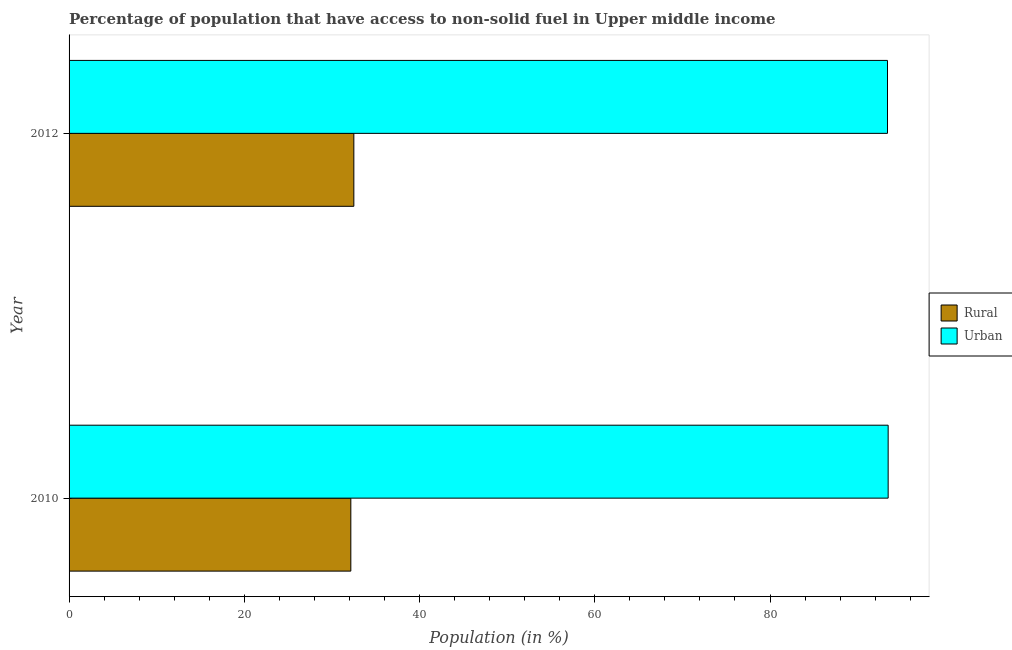Are the number of bars per tick equal to the number of legend labels?
Give a very brief answer. Yes. Are the number of bars on each tick of the Y-axis equal?
Offer a terse response. Yes. In how many cases, is the number of bars for a given year not equal to the number of legend labels?
Your response must be concise. 0. What is the rural population in 2012?
Your answer should be very brief. 32.5. Across all years, what is the maximum rural population?
Make the answer very short. 32.5. Across all years, what is the minimum urban population?
Your answer should be very brief. 93.41. In which year was the urban population maximum?
Give a very brief answer. 2010. What is the total rural population in the graph?
Provide a succinct answer. 64.66. What is the difference between the rural population in 2010 and that in 2012?
Offer a very short reply. -0.34. What is the difference between the urban population in 2010 and the rural population in 2012?
Give a very brief answer. 60.98. What is the average rural population per year?
Offer a very short reply. 32.33. In the year 2010, what is the difference between the urban population and rural population?
Keep it short and to the point. 61.33. In how many years, is the rural population greater than 32 %?
Keep it short and to the point. 2. What is the ratio of the rural population in 2010 to that in 2012?
Offer a terse response. 0.99. Is the urban population in 2010 less than that in 2012?
Ensure brevity in your answer.  No. What does the 1st bar from the top in 2010 represents?
Your answer should be very brief. Urban. What does the 2nd bar from the bottom in 2010 represents?
Give a very brief answer. Urban. How many bars are there?
Give a very brief answer. 4. Are the values on the major ticks of X-axis written in scientific E-notation?
Your answer should be very brief. No. Does the graph contain any zero values?
Offer a very short reply. No. Does the graph contain grids?
Provide a short and direct response. No. How many legend labels are there?
Offer a terse response. 2. What is the title of the graph?
Offer a very short reply. Percentage of population that have access to non-solid fuel in Upper middle income. Does "Travel Items" appear as one of the legend labels in the graph?
Make the answer very short. No. What is the Population (in %) of Rural in 2010?
Provide a succinct answer. 32.16. What is the Population (in %) of Urban in 2010?
Keep it short and to the point. 93.49. What is the Population (in %) in Rural in 2012?
Provide a succinct answer. 32.5. What is the Population (in %) of Urban in 2012?
Offer a very short reply. 93.41. Across all years, what is the maximum Population (in %) of Rural?
Your answer should be very brief. 32.5. Across all years, what is the maximum Population (in %) of Urban?
Give a very brief answer. 93.49. Across all years, what is the minimum Population (in %) in Rural?
Keep it short and to the point. 32.16. Across all years, what is the minimum Population (in %) in Urban?
Give a very brief answer. 93.41. What is the total Population (in %) of Rural in the graph?
Ensure brevity in your answer.  64.66. What is the total Population (in %) of Urban in the graph?
Give a very brief answer. 186.9. What is the difference between the Population (in %) of Rural in 2010 and that in 2012?
Provide a short and direct response. -0.34. What is the difference between the Population (in %) of Urban in 2010 and that in 2012?
Your response must be concise. 0.08. What is the difference between the Population (in %) in Rural in 2010 and the Population (in %) in Urban in 2012?
Make the answer very short. -61.25. What is the average Population (in %) of Rural per year?
Keep it short and to the point. 32.33. What is the average Population (in %) in Urban per year?
Provide a short and direct response. 93.45. In the year 2010, what is the difference between the Population (in %) in Rural and Population (in %) in Urban?
Offer a terse response. -61.33. In the year 2012, what is the difference between the Population (in %) of Rural and Population (in %) of Urban?
Make the answer very short. -60.91. What is the ratio of the Population (in %) of Rural in 2010 to that in 2012?
Provide a short and direct response. 0.99. What is the ratio of the Population (in %) in Urban in 2010 to that in 2012?
Keep it short and to the point. 1. What is the difference between the highest and the second highest Population (in %) in Rural?
Give a very brief answer. 0.34. What is the difference between the highest and the second highest Population (in %) of Urban?
Your answer should be compact. 0.08. What is the difference between the highest and the lowest Population (in %) in Rural?
Give a very brief answer. 0.34. What is the difference between the highest and the lowest Population (in %) in Urban?
Keep it short and to the point. 0.08. 